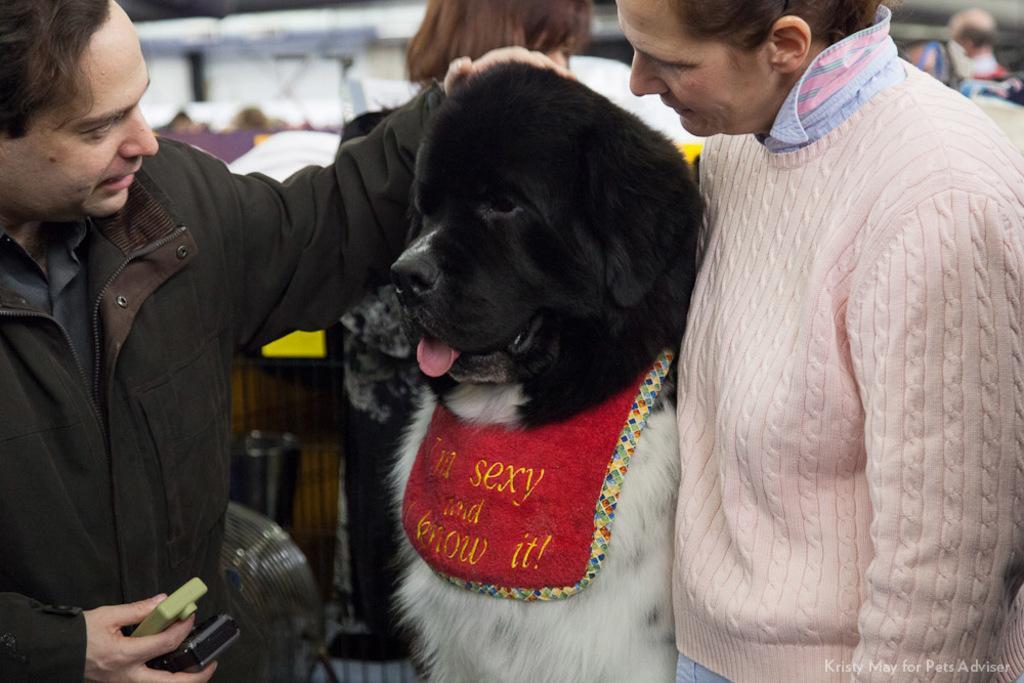In one or two sentences, can you explain what this image depicts? In this image I can see few people and black color of dog. 